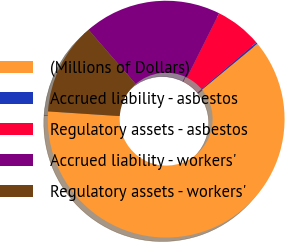<chart> <loc_0><loc_0><loc_500><loc_500><pie_chart><fcel>(Millions of Dollars)<fcel>Accrued liability - asbestos<fcel>Regulatory assets - asbestos<fcel>Accrued liability - workers'<fcel>Regulatory assets - workers'<nl><fcel>62.04%<fcel>0.22%<fcel>6.4%<fcel>18.76%<fcel>12.58%<nl></chart> 